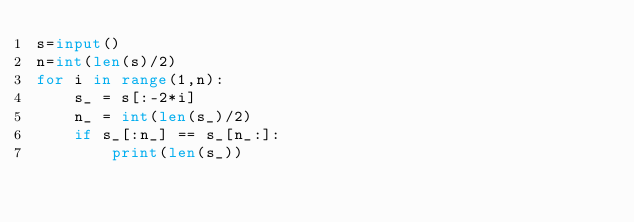Convert code to text. <code><loc_0><loc_0><loc_500><loc_500><_Python_>s=input()
n=int(len(s)/2)
for i in range(1,n):
    s_ = s[:-2*i]
    n_ = int(len(s_)/2)
    if s_[:n_] == s_[n_:]:
        print(len(s_))</code> 